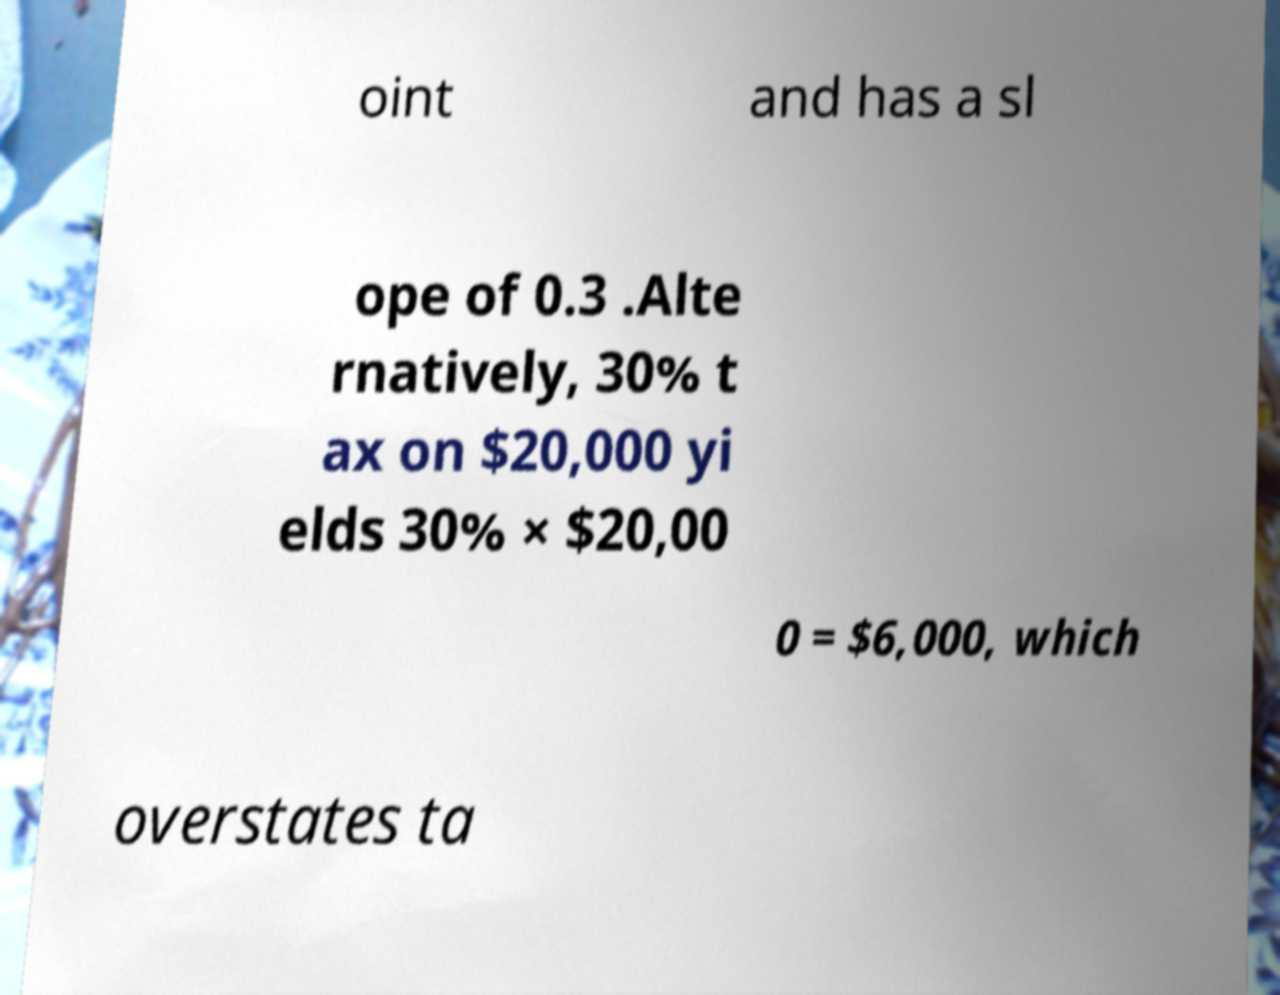Please read and relay the text visible in this image. What does it say? oint and has a sl ope of 0.3 .Alte rnatively, 30% t ax on $20,000 yi elds 30% × $20,00 0 = $6,000, which overstates ta 